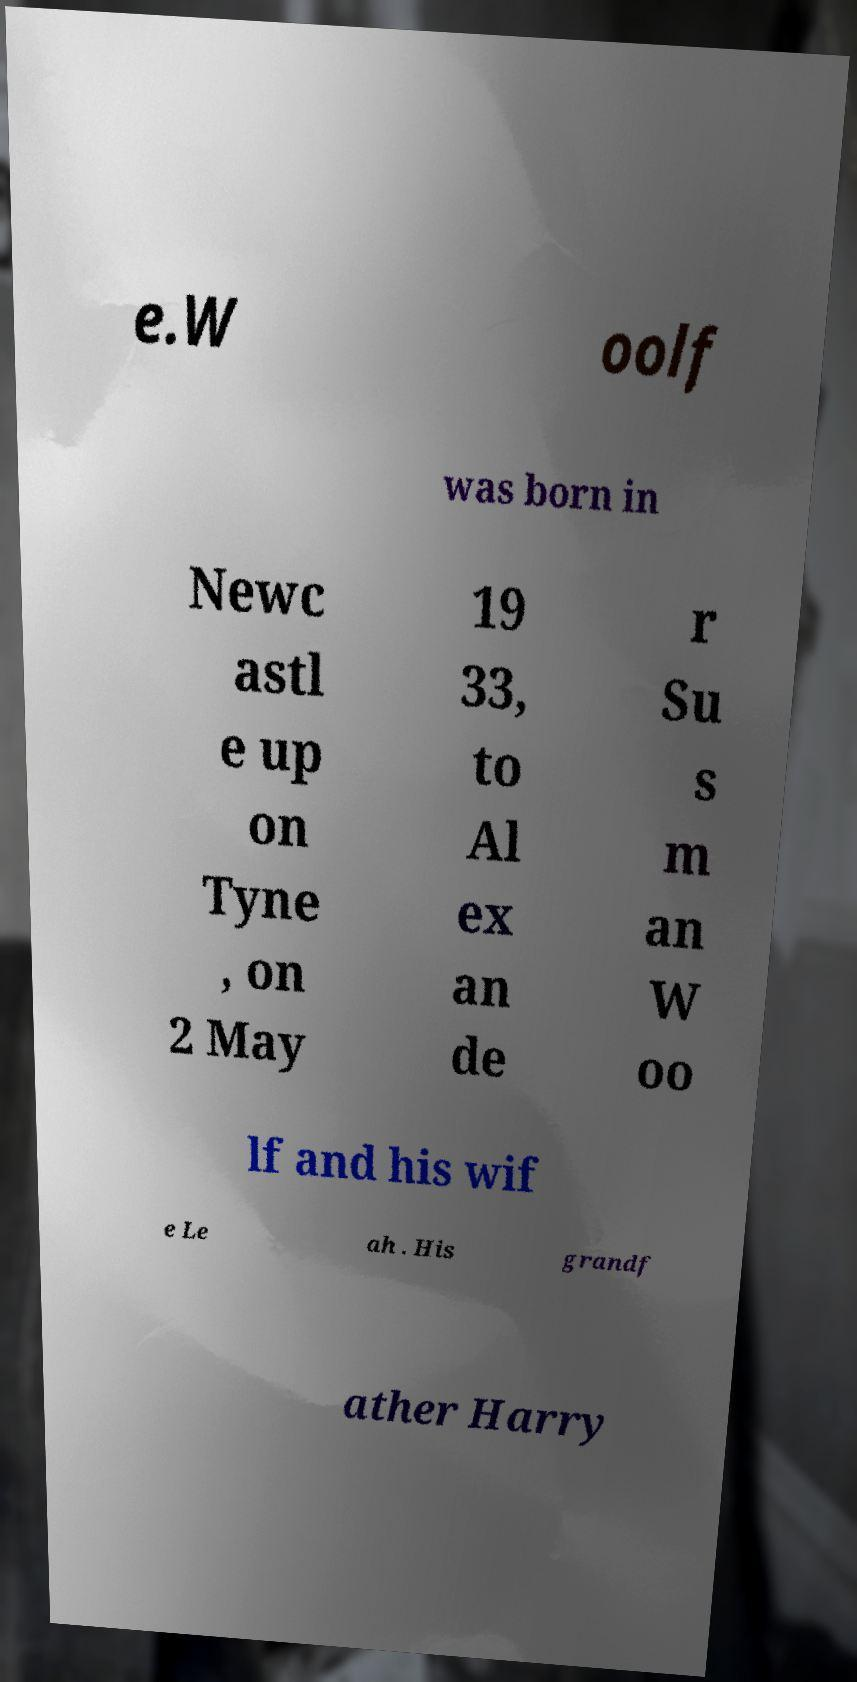There's text embedded in this image that I need extracted. Can you transcribe it verbatim? e.W oolf was born in Newc astl e up on Tyne , on 2 May 19 33, to Al ex an de r Su s m an W oo lf and his wif e Le ah . His grandf ather Harry 